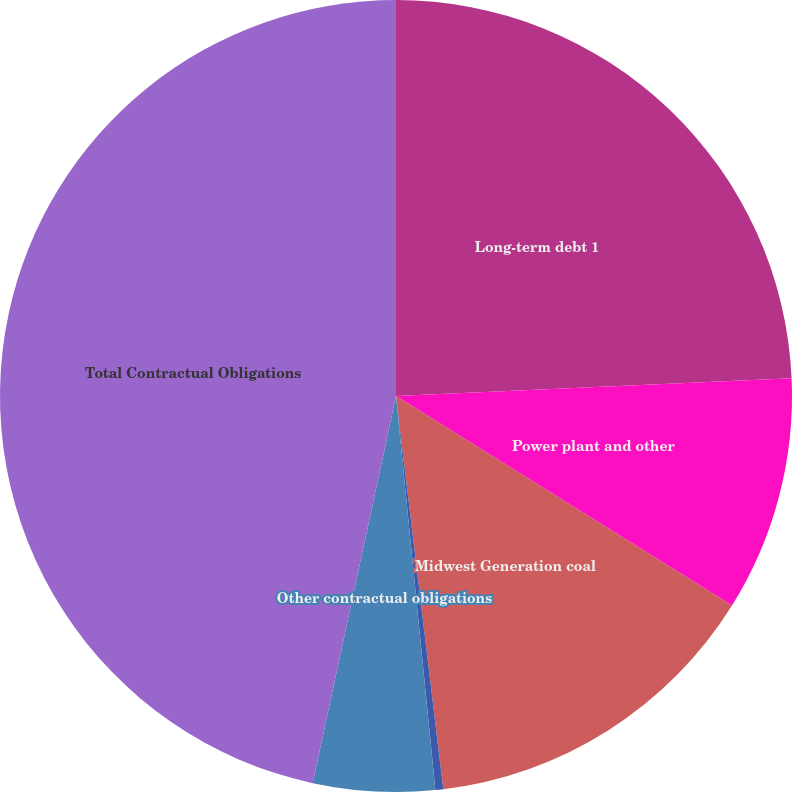Convert chart. <chart><loc_0><loc_0><loc_500><loc_500><pie_chart><fcel>Long-term debt 1<fcel>Power plant and other<fcel>Midwest Generation coal<fcel>Gas transportation agreements<fcel>Other contractual obligations<fcel>Total Contractual Obligations<nl><fcel>24.29%<fcel>9.59%<fcel>14.22%<fcel>0.32%<fcel>4.96%<fcel>46.63%<nl></chart> 